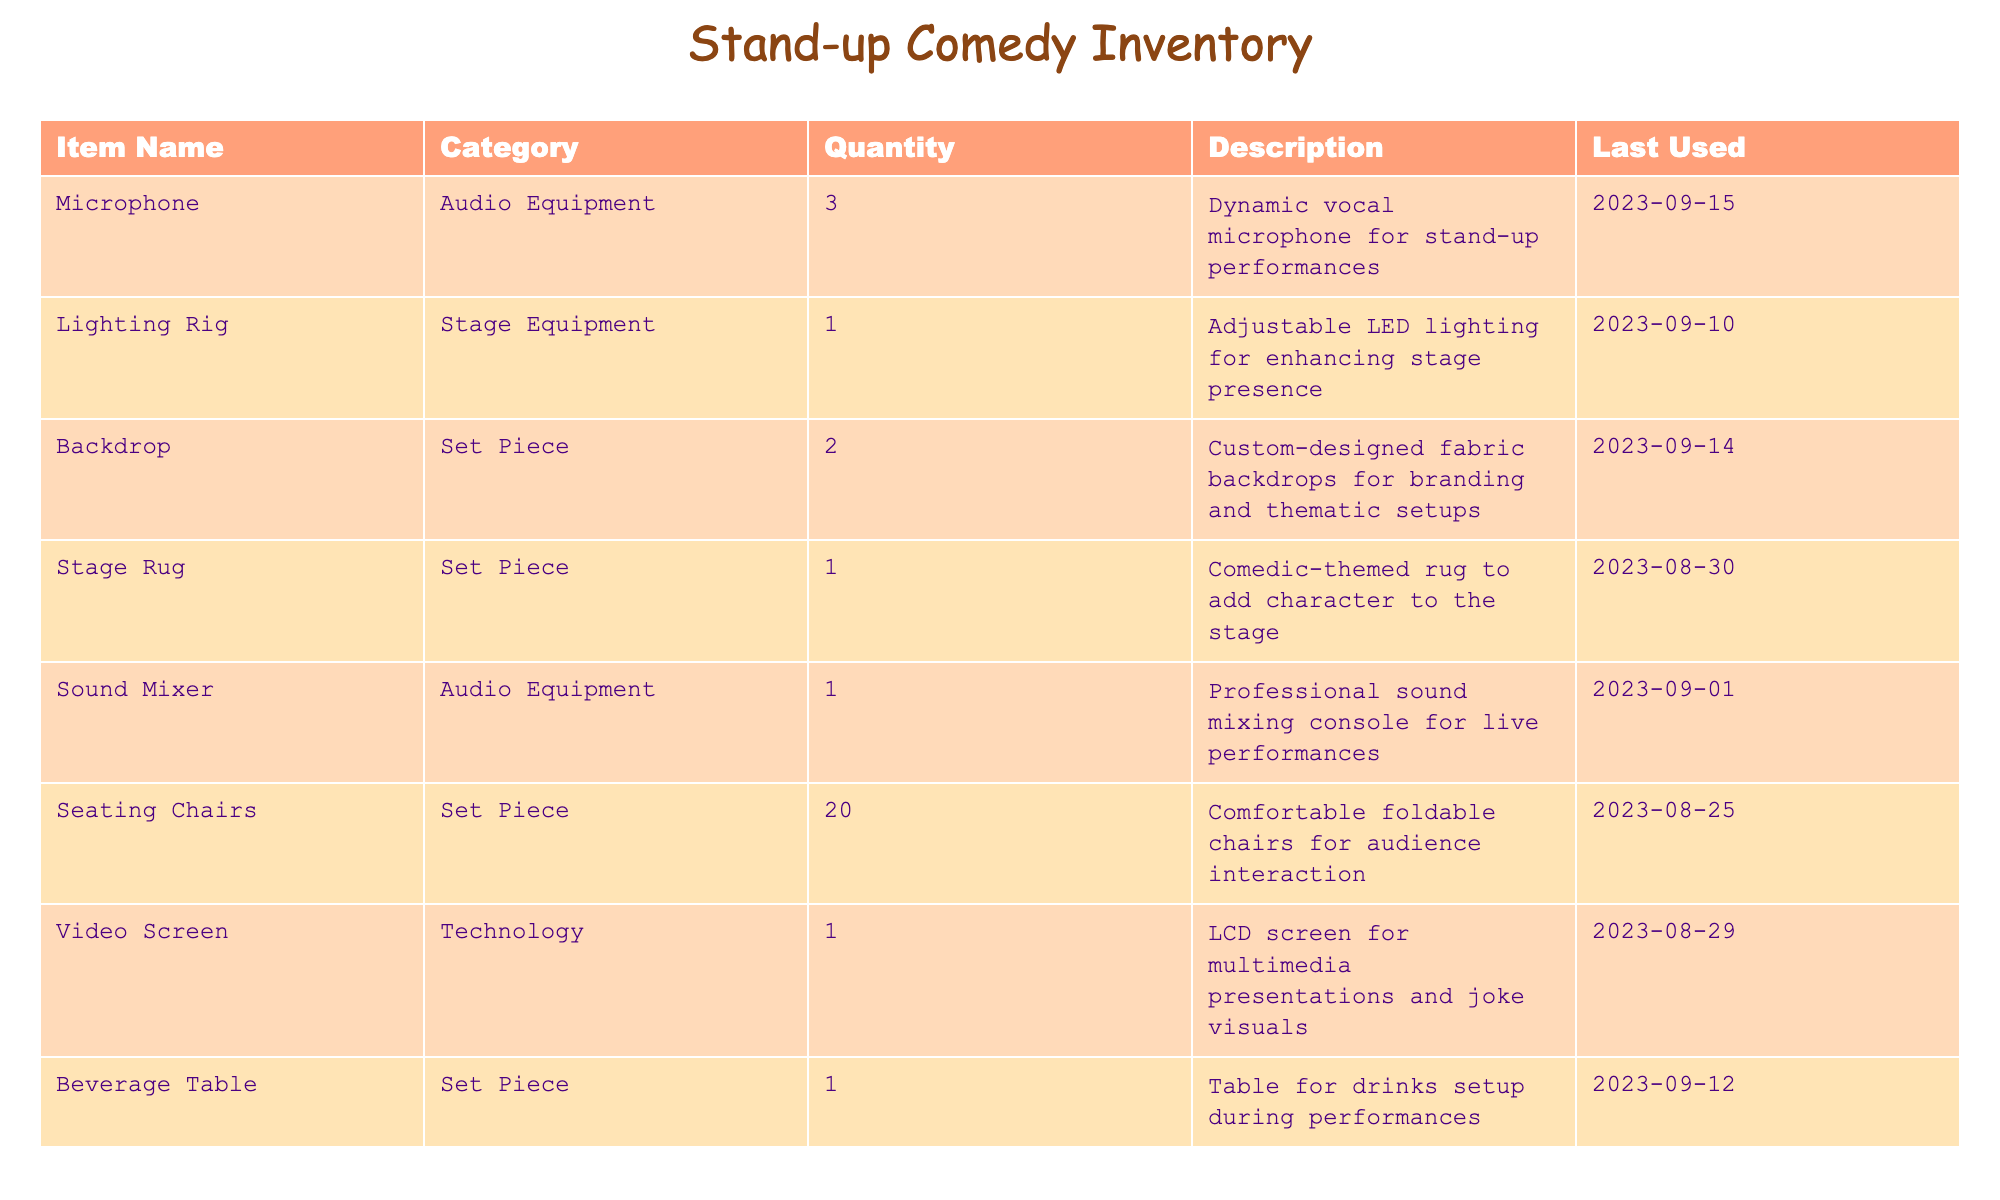What is the last date the Stage Rug was used? The last used date for the Stage Rug is listed in the table as "2023-08-30."
Answer: 2023-08-30 How many pieces of Audio Equipment are available? The two items in the Audio Equipment category are the Microphone and Sound Mixer. Summing their quantity gives us 3 (Microphone) + 1 (Sound Mixer) = 4.
Answer: 4 Is the Lighting Rig used in the performances? The last used date for the Lighting Rig is "2023-09-10," which indicates that it is still in use for performances.
Answer: Yes What is the total number of Set Pieces in the inventory? The Set Piece category includes Backdrop, Stage Rug, Seating Chairs, and Beverage Table. Their quantities sum as follows: 2 (Backdrop) + 1 (Stage Rug) + 20 (Seating Chairs) + 1 (Beverage Table) = 24.
Answer: 24 Which item has the highest quantity, and what is that quantity? The quantity of each item is considered; Seating Chairs have the highest quantity at 20, compared to other items.
Answer: Seating Chairs, 20 